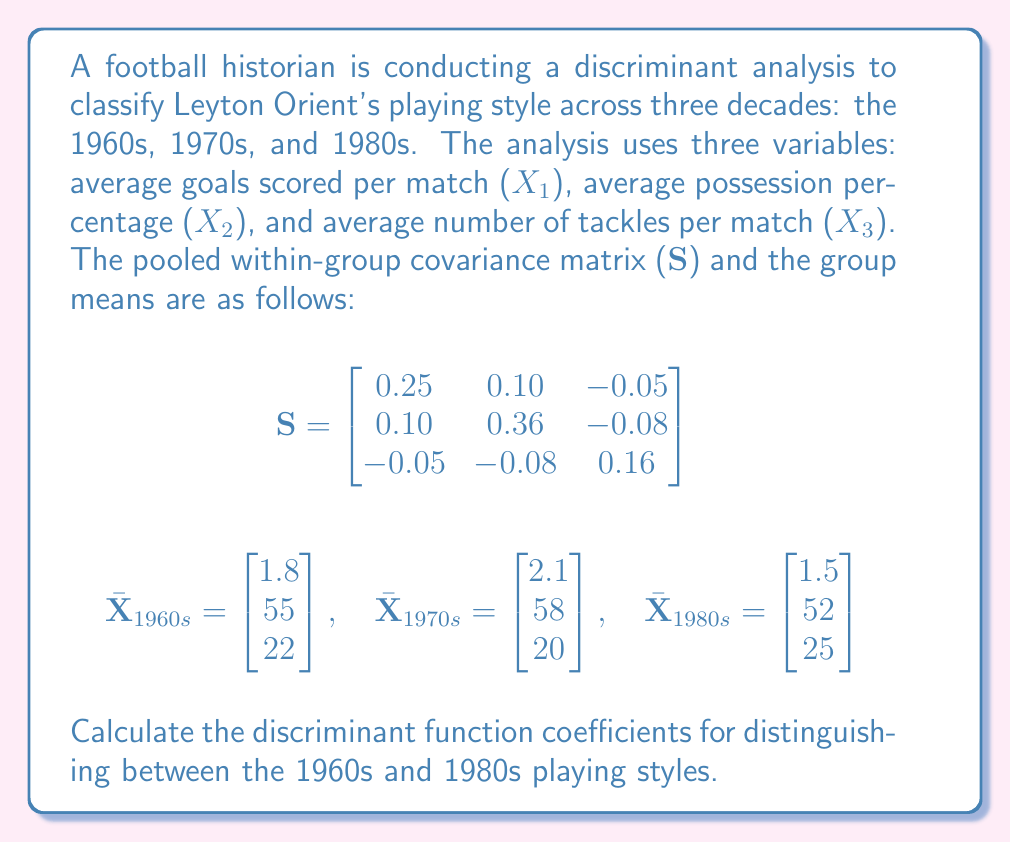Give your solution to this math problem. To calculate the discriminant function coefficients for distinguishing between the 1960s and 1980s playing styles, we'll follow these steps:

1) The linear discriminant function coefficient vector is given by:
   
   $$a = S^{-1}(\bar{X}_1 - \bar{X}_2)$$
   
   where $\bar{X}_1$ is the mean vector for the 1960s and $\bar{X}_2$ is the mean vector for the 1980s.

2) First, we need to find the inverse of the pooled within-group covariance matrix S:
   
   $$S^{-1} = \begin{bmatrix}
   4.4305 & -1.1494 & 1.3258 \\
   -1.1494 & 3.1768 & 1.3930 \\
   1.3258 & 1.3930 & 7.2485
   \end{bmatrix}$$

3) Next, we calculate the difference between the mean vectors:
   
   $$\bar{X}_{1960s} - \bar{X}_{1980s} = \begin{bmatrix} 1.8 \\ 55 \\ 22 \end{bmatrix} - \begin{bmatrix} 1.5 \\ 52 \\ 25 \end{bmatrix} = \begin{bmatrix} 0.3 \\ 3 \\ -3 \end{bmatrix}$$

4) Now we can multiply $S^{-1}$ by $(\bar{X}_{1960s} - \bar{X}_{1980s})$:
   
   $$a = \begin{bmatrix}
   4.4305 & -1.1494 & 1.3258 \\
   -1.1494 & 3.1768 & 1.3930 \\
   1.3258 & 1.3930 & 7.2485
   \end{bmatrix} \times \begin{bmatrix} 0.3 \\ 3 \\ -3 \end{bmatrix}$$

5) Performing this matrix multiplication:
   
   $$a = \begin{bmatrix}
   4.4305(0.3) + (-1.1494)(3) + 1.3258(-3) \\
   (-1.1494)(0.3) + 3.1768(3) + 1.3930(-3) \\
   1.3258(0.3) + 1.3930(3) + 7.2485(-3)
   \end{bmatrix}$$

6) Simplifying:
   
   $$a = \begin{bmatrix}
   1.3292 - 3.4482 - 3.9774 \\
   -0.3448 + 9.5304 - 4.1790 \\
   0.3977 + 4.1790 - 21.7455
   \end{bmatrix} = \begin{bmatrix}
   -6.0964 \\
   5.0066 \\
   -17.1688
   \end{bmatrix}$$
Answer: The discriminant function coefficients for distinguishing between the 1960s and 1980s playing styles are:

$$a = \begin{bmatrix}
-6.0964 \\
5.0066 \\
-17.1688
\end{bmatrix}$$ 